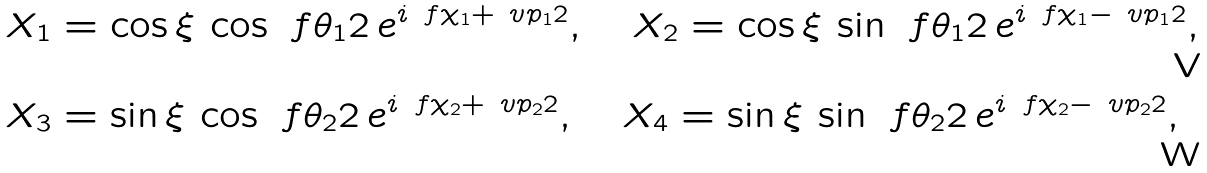<formula> <loc_0><loc_0><loc_500><loc_500>X _ { 1 } & = \cos \xi \, \cos \ f { \theta _ { 1 } } { 2 } \, e ^ { i \ f { \chi _ { 1 } + \ v p _ { 1 } } { 2 } } , \quad X _ { 2 } = \cos \xi \, \sin \ f { \theta _ { 1 } } { 2 } \, e ^ { i \ f { \chi _ { 1 } - \ v p _ { 1 } } { 2 } } , \\ X _ { 3 } & = \sin \xi \, \cos \ f { \theta _ { 2 } } { 2 } \, e ^ { i \ f { \chi _ { 2 } + \ v p _ { 2 } } { 2 } } , \quad X _ { 4 } = \sin \xi \, \sin \ f { \theta _ { 2 } } { 2 } \, e ^ { i \ f { \chi _ { 2 } - \ v p _ { 2 } } { 2 } } ,</formula> 